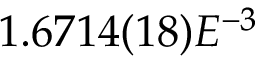Convert formula to latex. <formula><loc_0><loc_0><loc_500><loc_500>1 . 6 7 1 4 ( 1 8 ) E ^ { - 3 }</formula> 